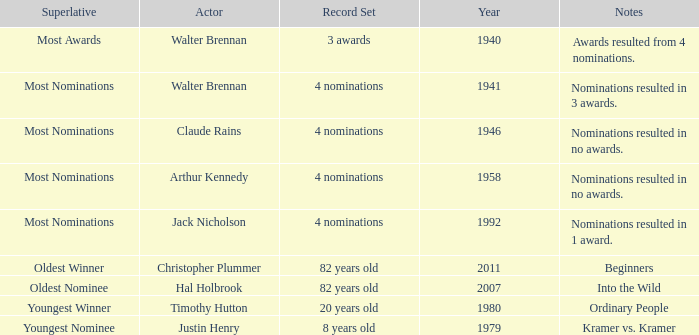What is the earliest year for ordinary people to appear in the notes? 1980.0. 